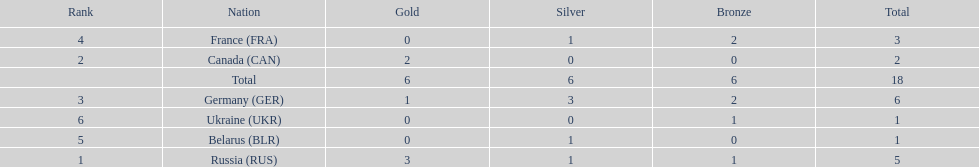Which country won more total medals than tue french, but less than the germans in the 1994 winter olympic biathlon? Russia. 